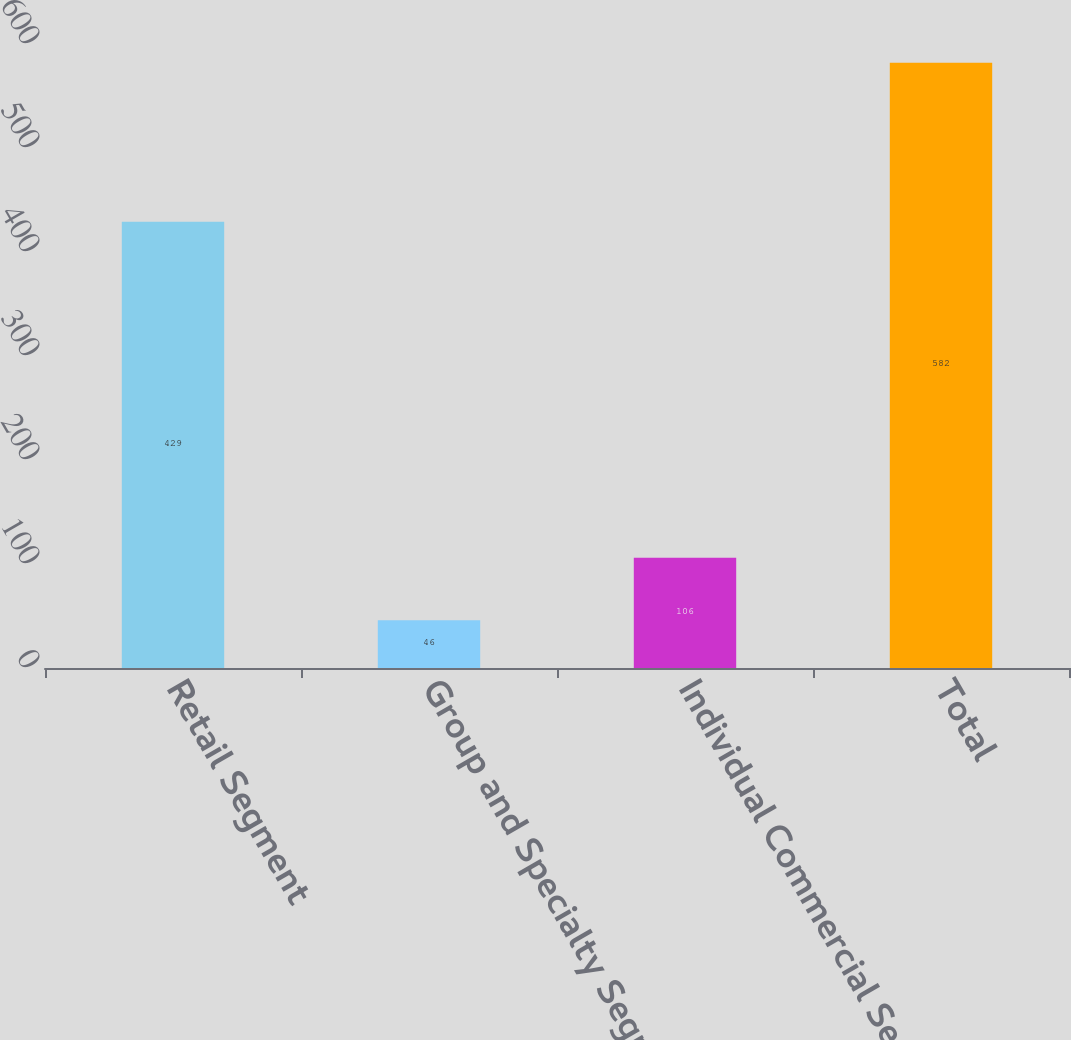Convert chart. <chart><loc_0><loc_0><loc_500><loc_500><bar_chart><fcel>Retail Segment<fcel>Group and Specialty Segment<fcel>Individual Commercial Segment<fcel>Total<nl><fcel>429<fcel>46<fcel>106<fcel>582<nl></chart> 